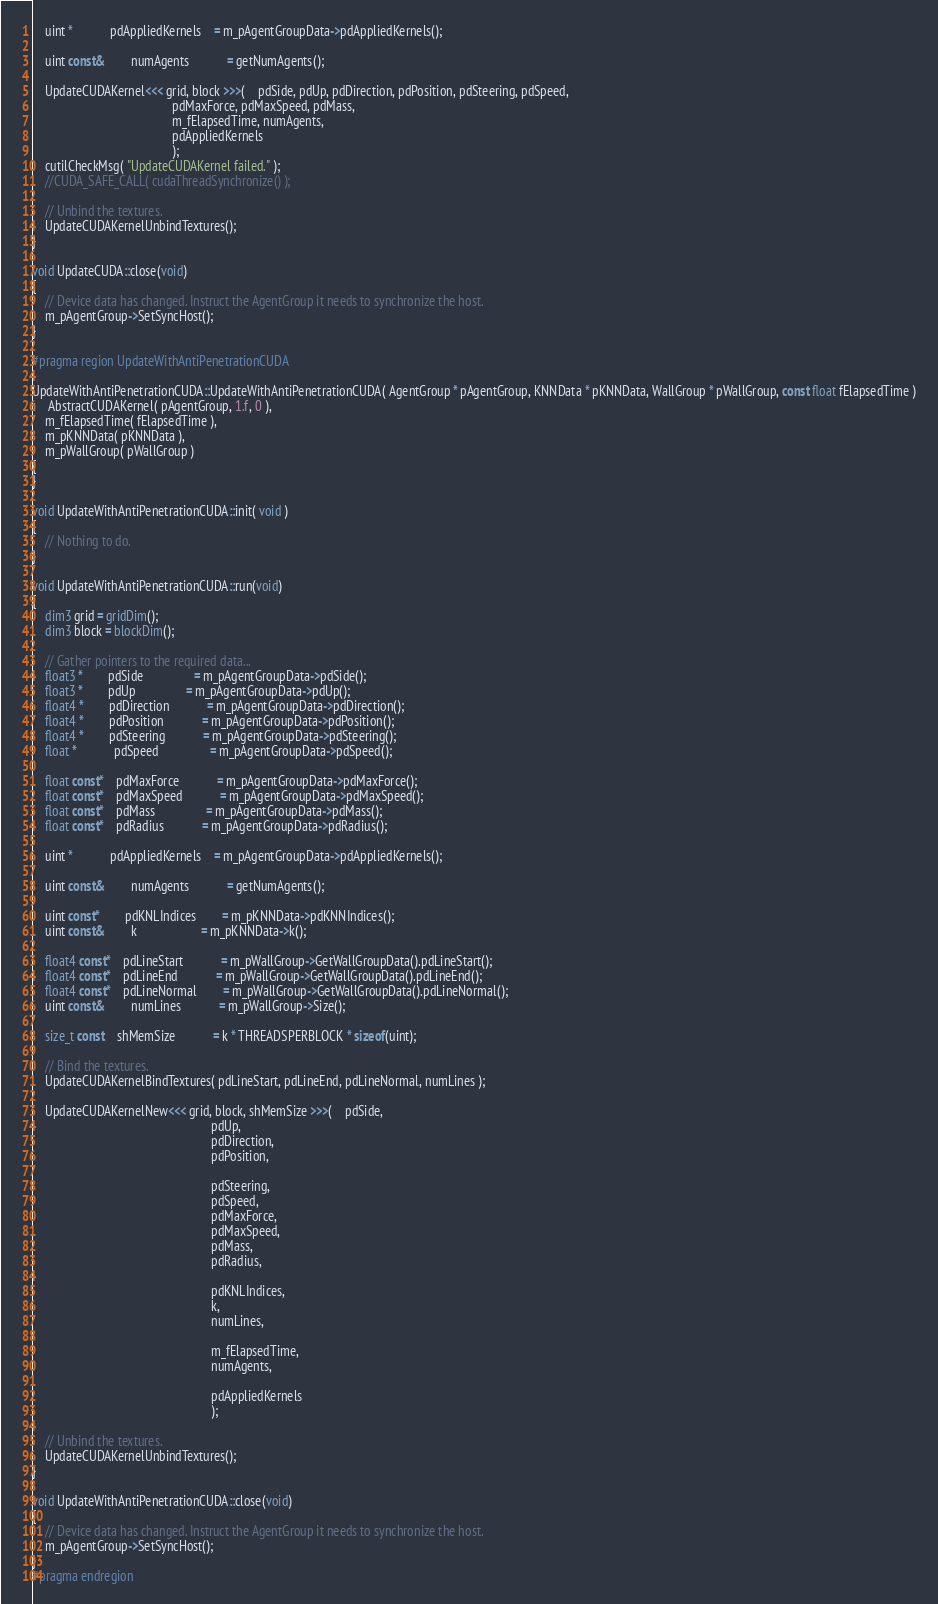Convert code to text. <code><loc_0><loc_0><loc_500><loc_500><_Cuda_>
	uint *			pdAppliedKernels	= m_pAgentGroupData->pdAppliedKernels();

	uint const&		numAgents			= getNumAgents();

	UpdateCUDAKernel<<< grid, block >>>(	pdSide, pdUp, pdDirection, pdPosition, pdSteering, pdSpeed,
											pdMaxForce, pdMaxSpeed, pdMass,
											m_fElapsedTime, numAgents,
											pdAppliedKernels
											);
	cutilCheckMsg( "UpdateCUDAKernel failed." );
	//CUDA_SAFE_CALL( cudaThreadSynchronize() );

	// Unbind the textures.
	UpdateCUDAKernelUnbindTextures();
}

void UpdateCUDA::close(void)
{
	// Device data has changed. Instruct the AgentGroup it needs to synchronize the host.
	m_pAgentGroup->SetSyncHost();
}

#pragma region UpdateWithAntiPenetrationCUDA

UpdateWithAntiPenetrationCUDA::UpdateWithAntiPenetrationCUDA( AgentGroup * pAgentGroup, KNNData * pKNNData, WallGroup * pWallGroup, const float fElapsedTime )
:	AbstractCUDAKernel( pAgentGroup, 1.f, 0 ),
	m_fElapsedTime( fElapsedTime ),
	m_pKNNData( pKNNData ),
	m_pWallGroup( pWallGroup )
{
}

void UpdateWithAntiPenetrationCUDA::init( void )
{
	// Nothing to do.
}

void UpdateWithAntiPenetrationCUDA::run(void)
{
	dim3 grid = gridDim();
	dim3 block = blockDim();

	// Gather pointers to the required data...
	float3 *		pdSide				= m_pAgentGroupData->pdSide();
	float3 *		pdUp				= m_pAgentGroupData->pdUp();
	float4 *		pdDirection			= m_pAgentGroupData->pdDirection();
	float4 *		pdPosition			= m_pAgentGroupData->pdPosition();
	float4 *		pdSteering			= m_pAgentGroupData->pdSteering();
	float *			pdSpeed				= m_pAgentGroupData->pdSpeed();

	float const*	pdMaxForce			= m_pAgentGroupData->pdMaxForce();
	float const*	pdMaxSpeed			= m_pAgentGroupData->pdMaxSpeed();
	float const*	pdMass				= m_pAgentGroupData->pdMass();
	float const*	pdRadius			= m_pAgentGroupData->pdRadius();

	uint *			pdAppliedKernels	= m_pAgentGroupData->pdAppliedKernels();

	uint const&		numAgents			= getNumAgents();

	uint const*		pdKNLIndices		= m_pKNNData->pdKNNIndices();
	uint const&		k					= m_pKNNData->k();

	float4 const*	pdLineStart			= m_pWallGroup->GetWallGroupData().pdLineStart();
	float4 const*	pdLineEnd			= m_pWallGroup->GetWallGroupData().pdLineEnd();
	float4 const*	pdLineNormal		= m_pWallGroup->GetWallGroupData().pdLineNormal();
	uint const&		numLines			= m_pWallGroup->Size();

	size_t const	shMemSize			= k * THREADSPERBLOCK * sizeof(uint);

	// Bind the textures.
	UpdateCUDAKernelBindTextures( pdLineStart, pdLineEnd, pdLineNormal, numLines );

	UpdateCUDAKernelNew<<< grid, block, shMemSize >>>(	pdSide,
														pdUp,
														pdDirection,
														pdPosition,

														pdSteering,
														pdSpeed,
														pdMaxForce,
														pdMaxSpeed,
														pdMass,
														pdRadius,

														pdKNLIndices,
														k,
														numLines,

														m_fElapsedTime,
														numAgents,

														pdAppliedKernels
														);

	// Unbind the textures.
	UpdateCUDAKernelUnbindTextures();
}

void UpdateWithAntiPenetrationCUDA::close(void)
{
	// Device data has changed. Instruct the AgentGroup it needs to synchronize the host.
	m_pAgentGroup->SetSyncHost();
}
#pragma endregion
</code> 